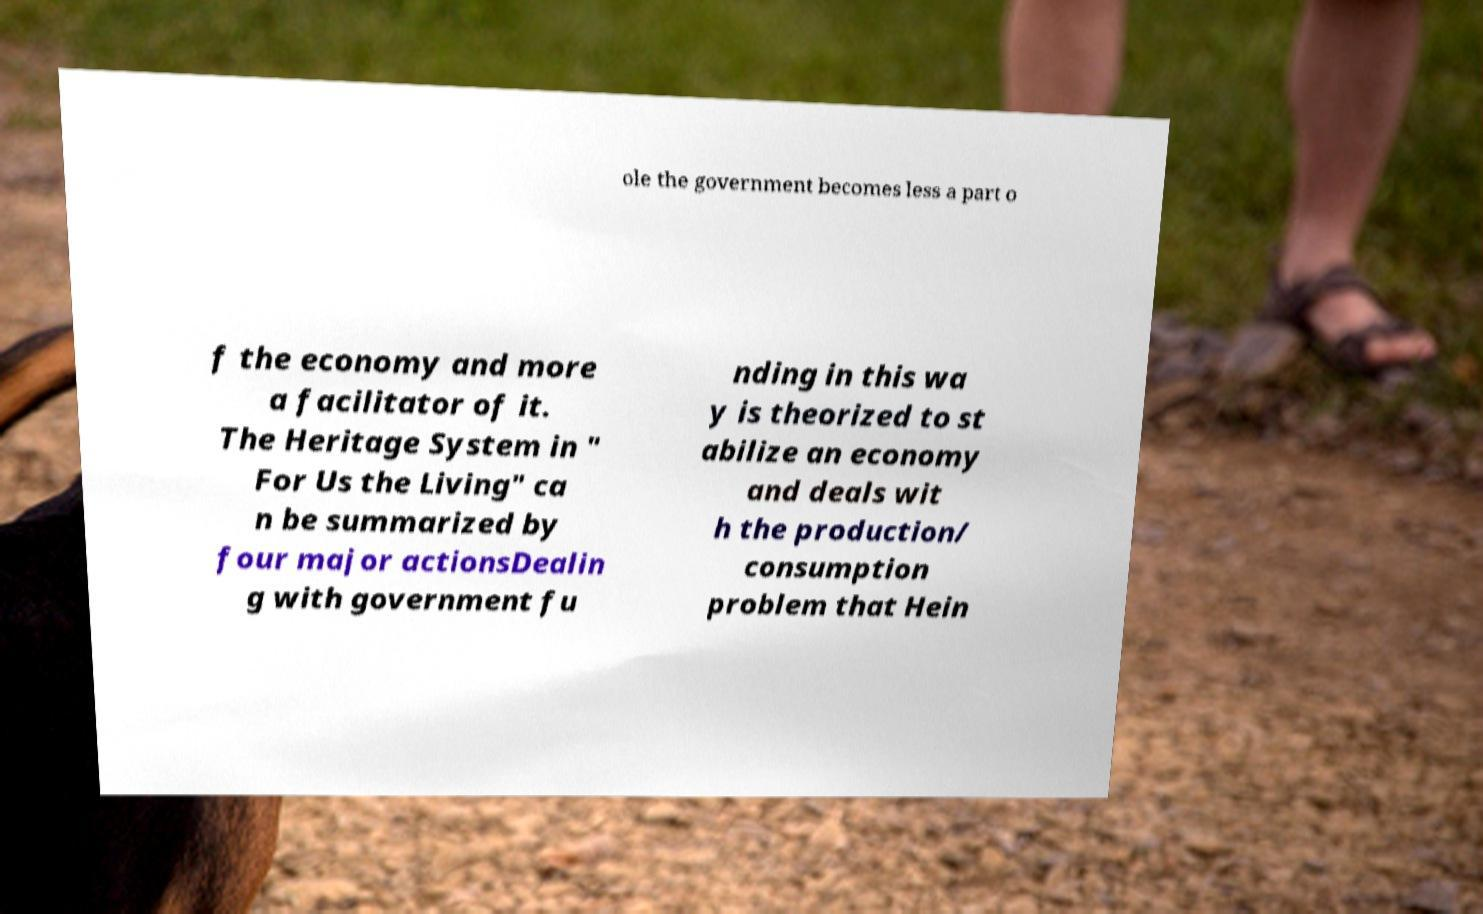Can you accurately transcribe the text from the provided image for me? ole the government becomes less a part o f the economy and more a facilitator of it. The Heritage System in " For Us the Living" ca n be summarized by four major actionsDealin g with government fu nding in this wa y is theorized to st abilize an economy and deals wit h the production/ consumption problem that Hein 